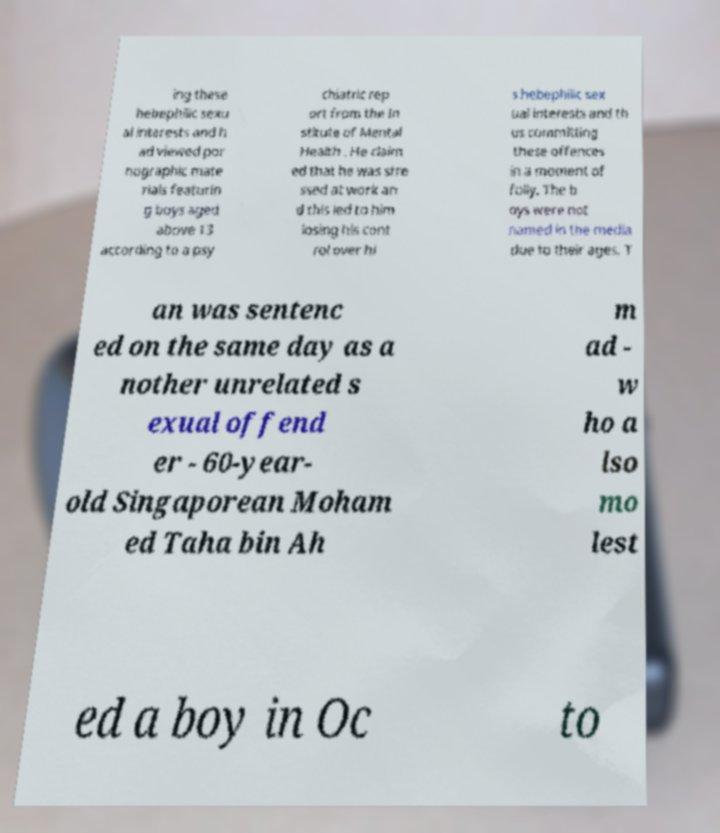There's text embedded in this image that I need extracted. Can you transcribe it verbatim? ing these hebephilic sexu al interests and h ad viewed por nographic mate rials featurin g boys aged above 13 according to a psy chiatric rep ort from the In stitute of Mental Health . He claim ed that he was stre ssed at work an d this led to him losing his cont rol over hi s hebephilic sex ual interests and th us committing these offences in a moment of folly. The b oys were not named in the media due to their ages. T an was sentenc ed on the same day as a nother unrelated s exual offend er - 60-year- old Singaporean Moham ed Taha bin Ah m ad - w ho a lso mo lest ed a boy in Oc to 